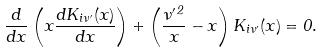<formula> <loc_0><loc_0><loc_500><loc_500>\frac { d } { d x } \left ( x \frac { d K _ { i \nu ^ { \prime } } ( x ) } { d x } \right ) + \left ( \frac { \nu ^ { \prime \, 2 } } { x } - x \right ) K _ { i \nu ^ { \prime } } ( x ) = 0 .</formula> 